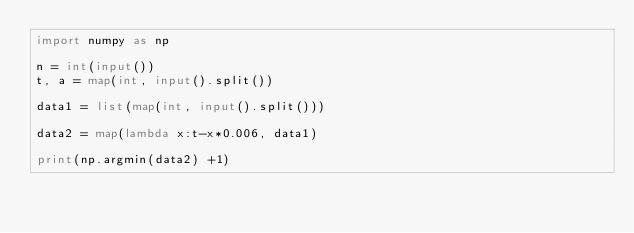Convert code to text. <code><loc_0><loc_0><loc_500><loc_500><_Python_>import numpy as np

n = int(input())
t, a = map(int, input().split())

data1 = list(map(int, input().split()))

data2 = map(lambda x:t-x*0.006, data1)

print(np.argmin(data2) +1)</code> 